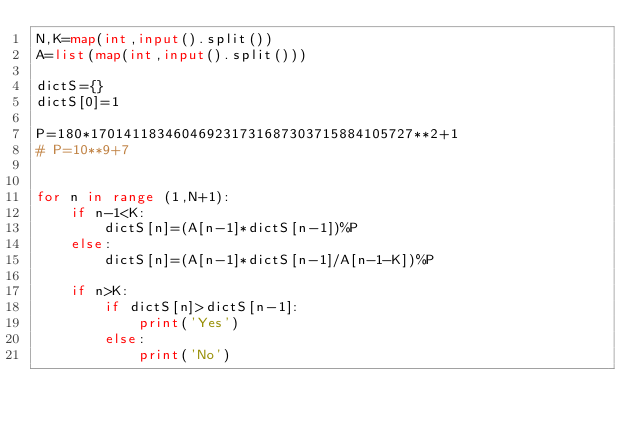Convert code to text. <code><loc_0><loc_0><loc_500><loc_500><_Python_>N,K=map(int,input().split())
A=list(map(int,input().split()))

dictS={}
dictS[0]=1

P=180*170141183460469231731687303715884105727**2+1
# P=10**9+7


for n in range (1,N+1):
    if n-1<K:
        dictS[n]=(A[n-1]*dictS[n-1])%P
    else:
        dictS[n]=(A[n-1]*dictS[n-1]/A[n-1-K])%P

    if n>K:
        if dictS[n]>dictS[n-1]:
            print('Yes')
        else:
            print('No')
</code> 